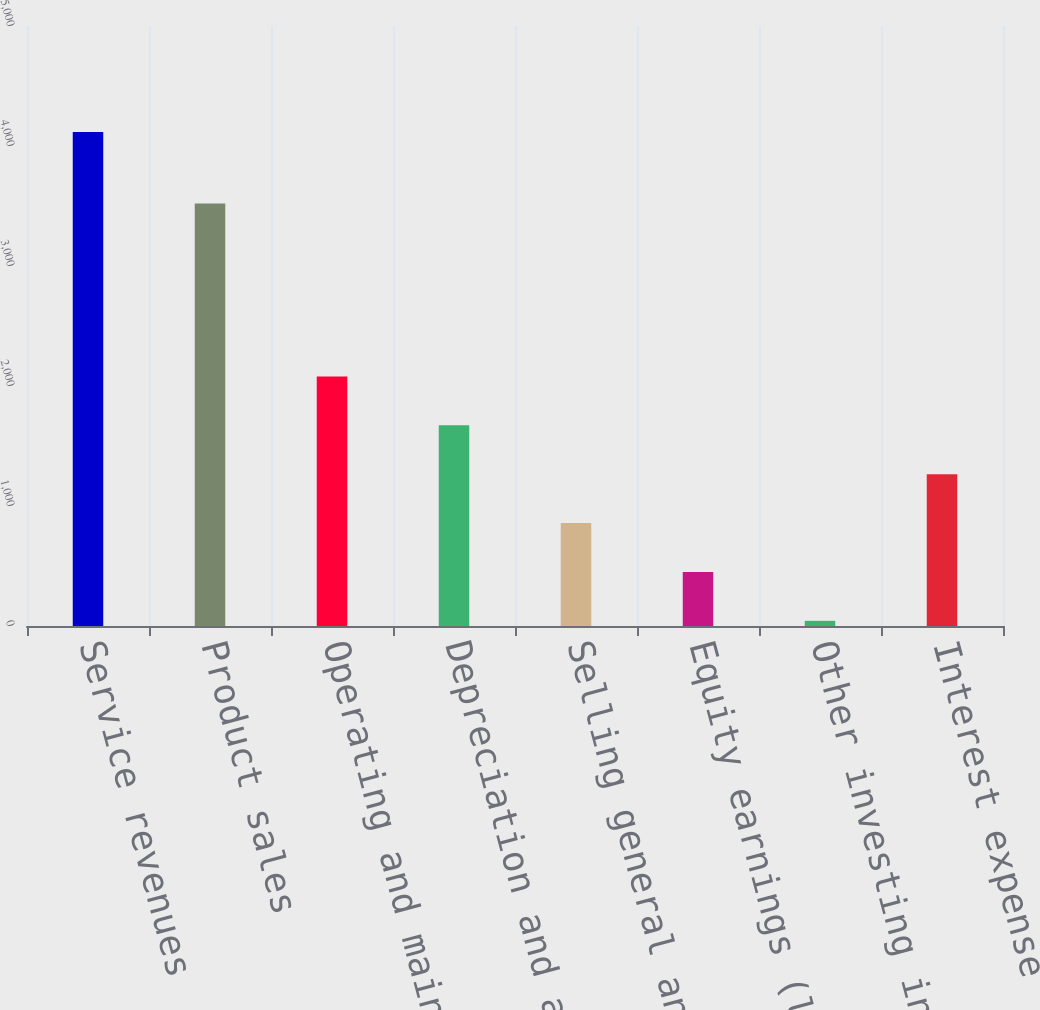Convert chart to OTSL. <chart><loc_0><loc_0><loc_500><loc_500><bar_chart><fcel>Service revenues<fcel>Product sales<fcel>Operating and maintenance<fcel>Depreciation and amortization<fcel>Selling general and<fcel>Equity earnings (losses)<fcel>Other investing income (loss)<fcel>Interest expense<nl><fcel>4116<fcel>3521<fcel>2079.5<fcel>1672.2<fcel>857.6<fcel>450.3<fcel>43<fcel>1264.9<nl></chart> 